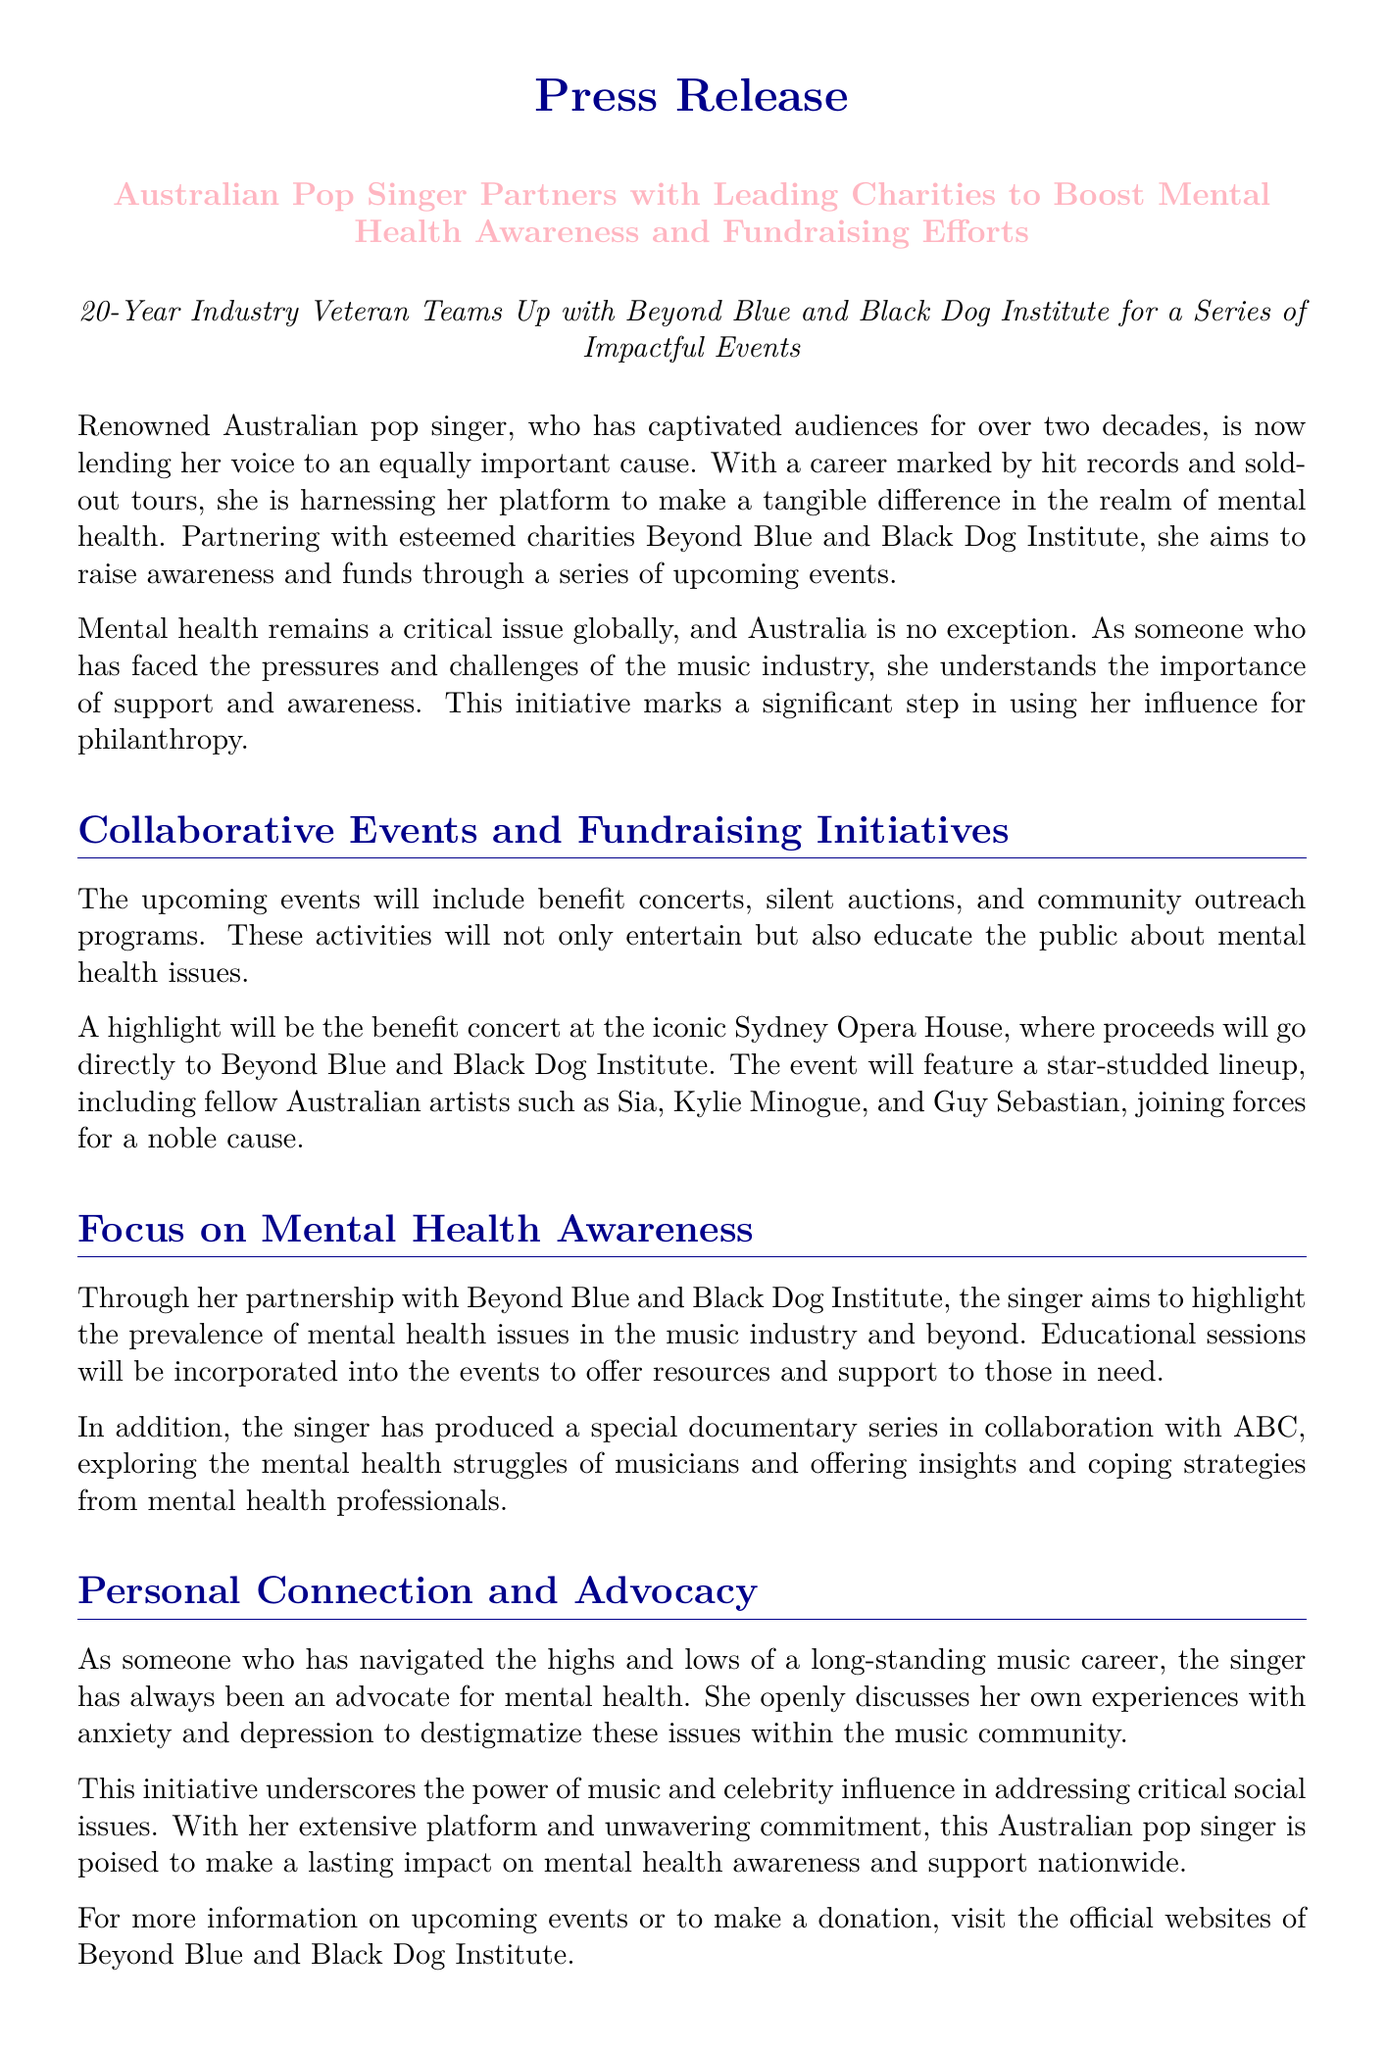what is the primary cause the singer is supporting? The primary cause being supported is mental health awareness.
Answer: mental health awareness which charities is the singer partnering with? The charities mentioned in the document are Beyond Blue and Black Dog Institute.
Answer: Beyond Blue and Black Dog Institute what type of event will be hosted at the Sydney Opera House? A benefit concert will be hosted at the Sydney Opera House.
Answer: benefit concert who are some of the artists participating in the benefit concert? The participating artists include Sia, Kylie Minogue, and Guy Sebastian.
Answer: Sia, Kylie Minogue, Guy Sebastian what issue does the singer personally relate to? The singer personally relates to anxiety and depression.
Answer: anxiety and depression how many years has the singer been in the music industry? The singer has been in the music industry for over 20 years.
Answer: over 20 years what unique media project is mentioned in the document? A special documentary series exploring mental health struggles is mentioned.
Answer: documentary series what format will educational sessions take at the events? Educational sessions will offer resources and support.
Answer: resources and support 